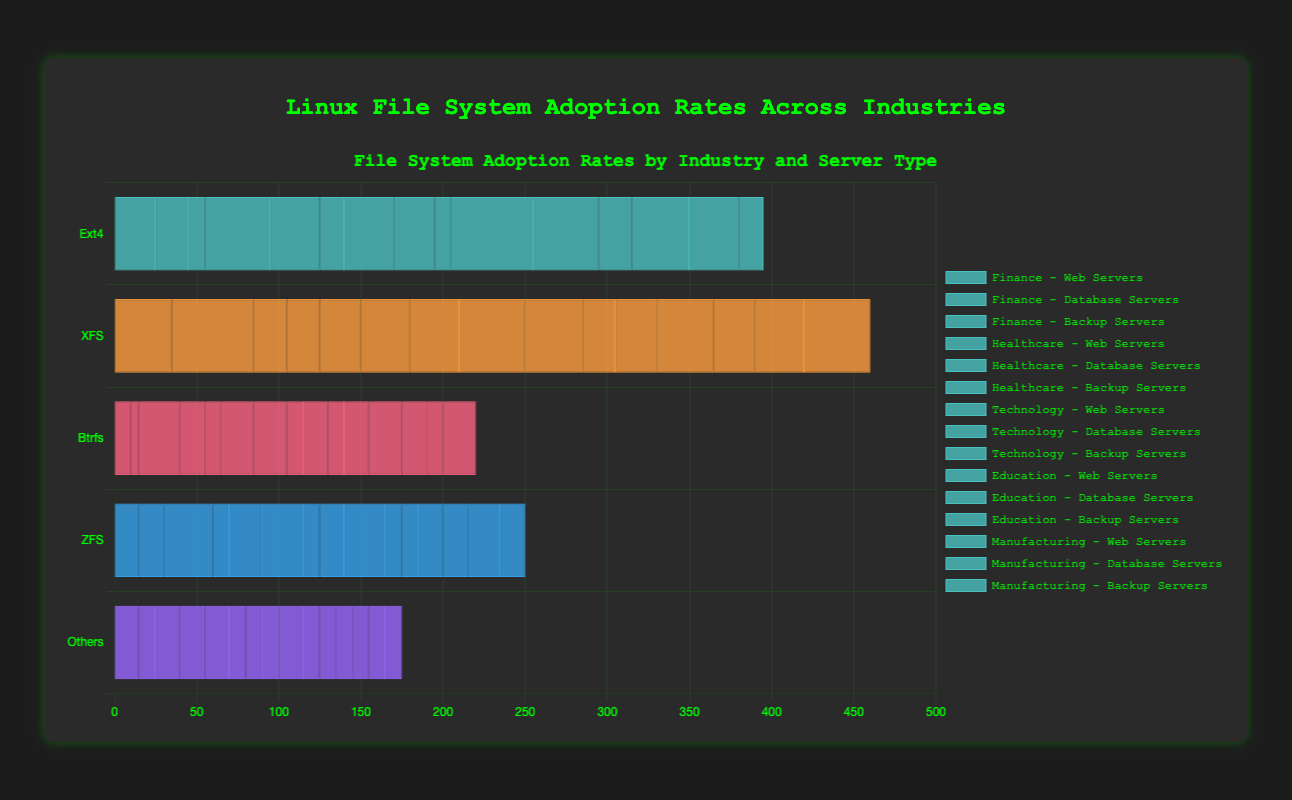What is the most common file system used for Web Servers in the Education industry? Look for the file system with the largest bar length in the Web Servers section of the Education industry.
Answer: Ext4 What is the total adoption percentage of Ext4 file systems in the Healthcare industry across all usage scenarios? Add the percentages of Ext4 for Web Servers (40%), Database Servers (30%), and Backup Servers (15%) in the Healthcare industry: 40 + 30 + 15.
Answer: 85% Which file system is most commonly used for Backup Servers in the Finance industry? Identify the longest bar in the Backup Servers section of the Finance industry.
Answer: ZFS Is the adoption of Btrfs higher in the Education industry for Database Servers or Backup Servers? Compare the lengths of the Btrfs bars in the Database Servers and Backup Servers sections of the Education industry.
Answer: Backup Servers Compare the adoption rates of ZFS and XFS for Database Servers in the Technology industry. Which one is higher? Check the bar lengths for ZFS and XFS in the Database Servers section of the Technology industry.
Answer: XFS What is the average adoption rate of file systems other than Ext4 across all Web Servers in the Manufacturing industry? Calculate the average by adding the percentages of XFS (25%), Btrfs (15%), ZFS (15%), and Others (10%) and dividing by 4: (25 + 15 + 15 + 10) / 4.
Answer: 16.25% Which industry has the highest adoption rate for XFS on Database Servers? Identify the Database Servers section across all industries and determine which has the longest XFS bar.
Answer: Finance What is the difference in ZFS usage between Web Servers and Backup Servers in the Technology industry? Subtract the ZFS percentage for Web Servers (10%) from Backup Servers (25%) in the Technology industry: 25 - 10.
Answer: 15% For which server type in the Finance industry is XFS least commonly used? Identify the shortest XFS bar among the Web Servers, Database Servers, and Backup Servers in the Finance industry.
Answer: Backup Servers In the Technology industry, what is the combined usage rate of Btrfs for all server types? Add the Btrfs percentages for Web Servers (20%), Database Servers (10%), and Backup Servers (15%) in the Technology industry: 20 + 10 + 15.
Answer: 45% 